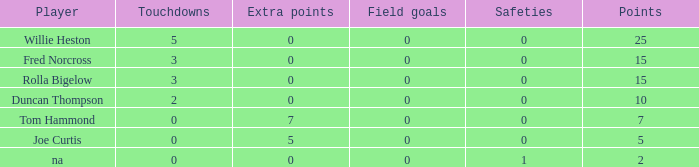Which Points is the lowest one that has Touchdowns smaller than 2, and an Extra points of 7, and a Field goals smaller than 0? None. 